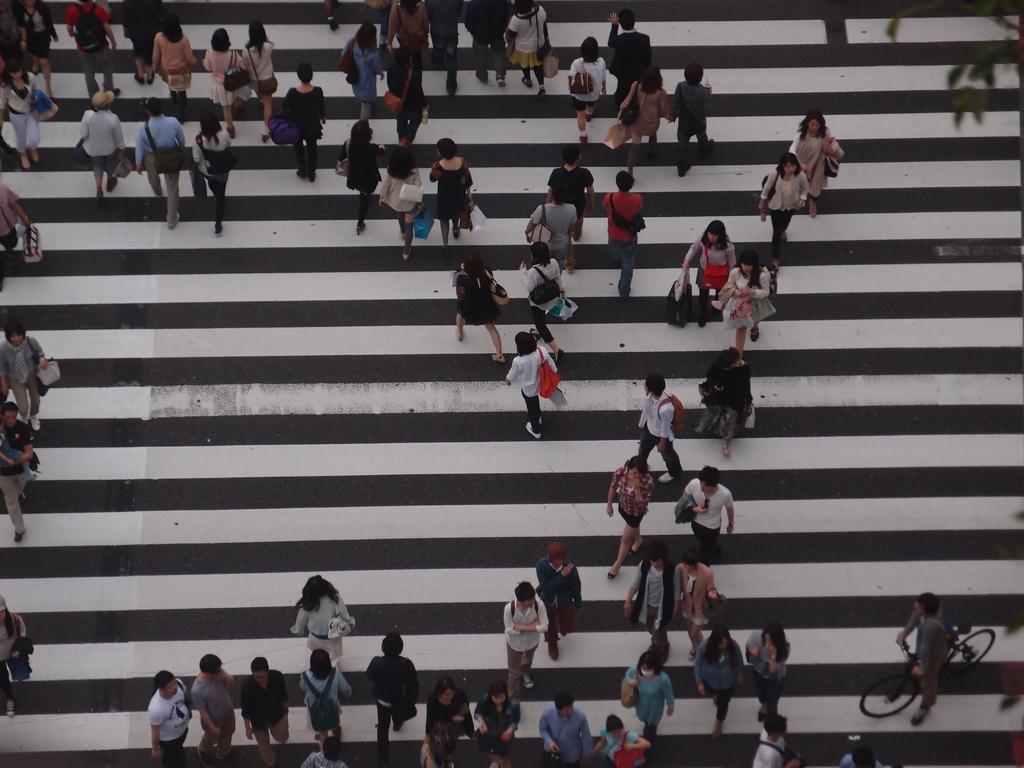How many persons are in the image? There are persons in the image. What can be observed about the dresses worn by the persons? The persons are wearing different color dresses. What are some of the persons holding in the image? Some of the persons are holding bags. Where are the persons located in the image? The persons are on a zebra crossing. Can you see any icicles hanging from the persons' dresses in the image? There are no icicles present in the image. How many geese are walking alongside the persons on the zebra crossing? There are no geese present in the image. 